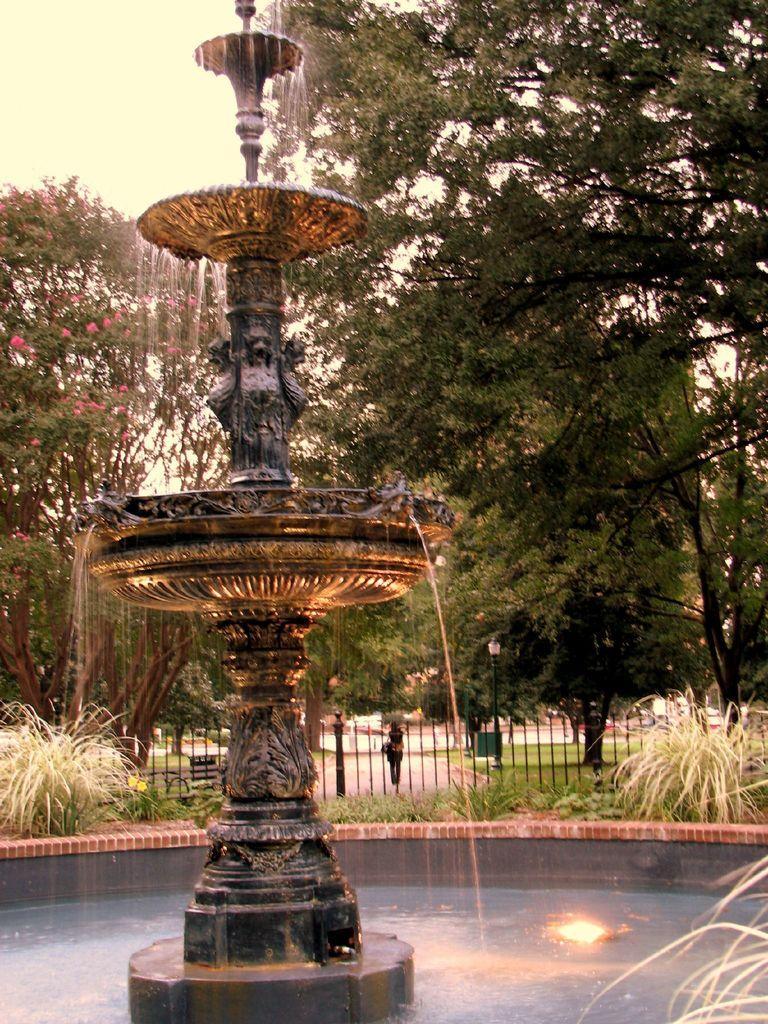Describe this image in one or two sentences. In this image I can see the fountain. At the bottom I can see the water. In the background there are many trees and I can see a person is walking on the road. Beside the road I can see the grass. At the top I can see the sky. 